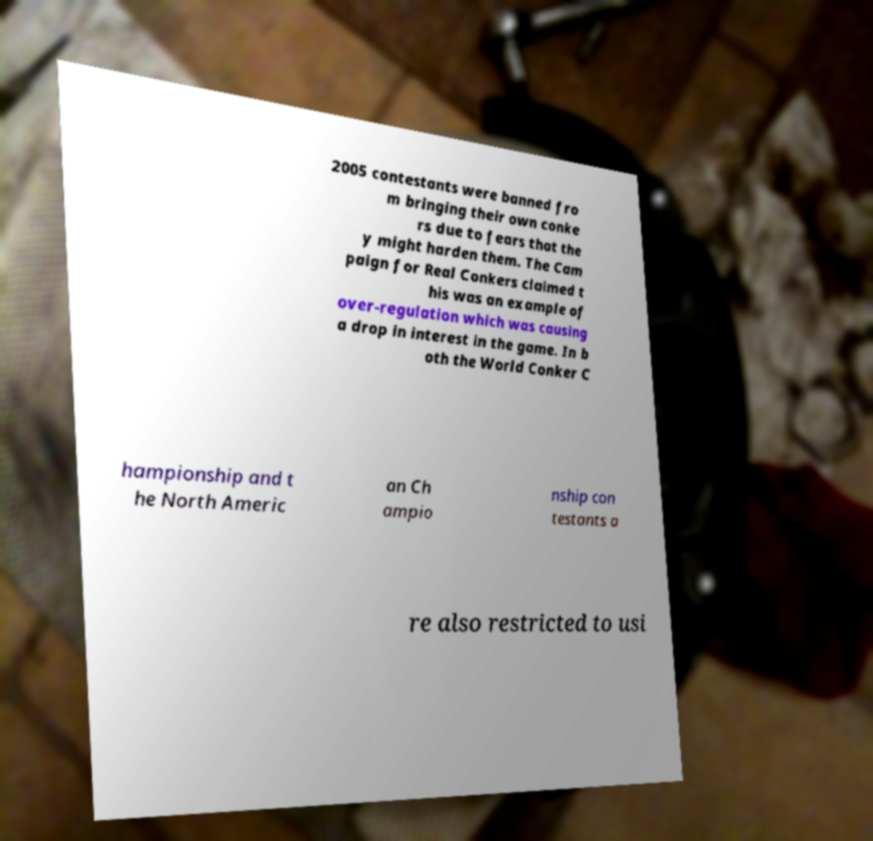Could you extract and type out the text from this image? 2005 contestants were banned fro m bringing their own conke rs due to fears that the y might harden them. The Cam paign for Real Conkers claimed t his was an example of over-regulation which was causing a drop in interest in the game. In b oth the World Conker C hampionship and t he North Americ an Ch ampio nship con testants a re also restricted to usi 